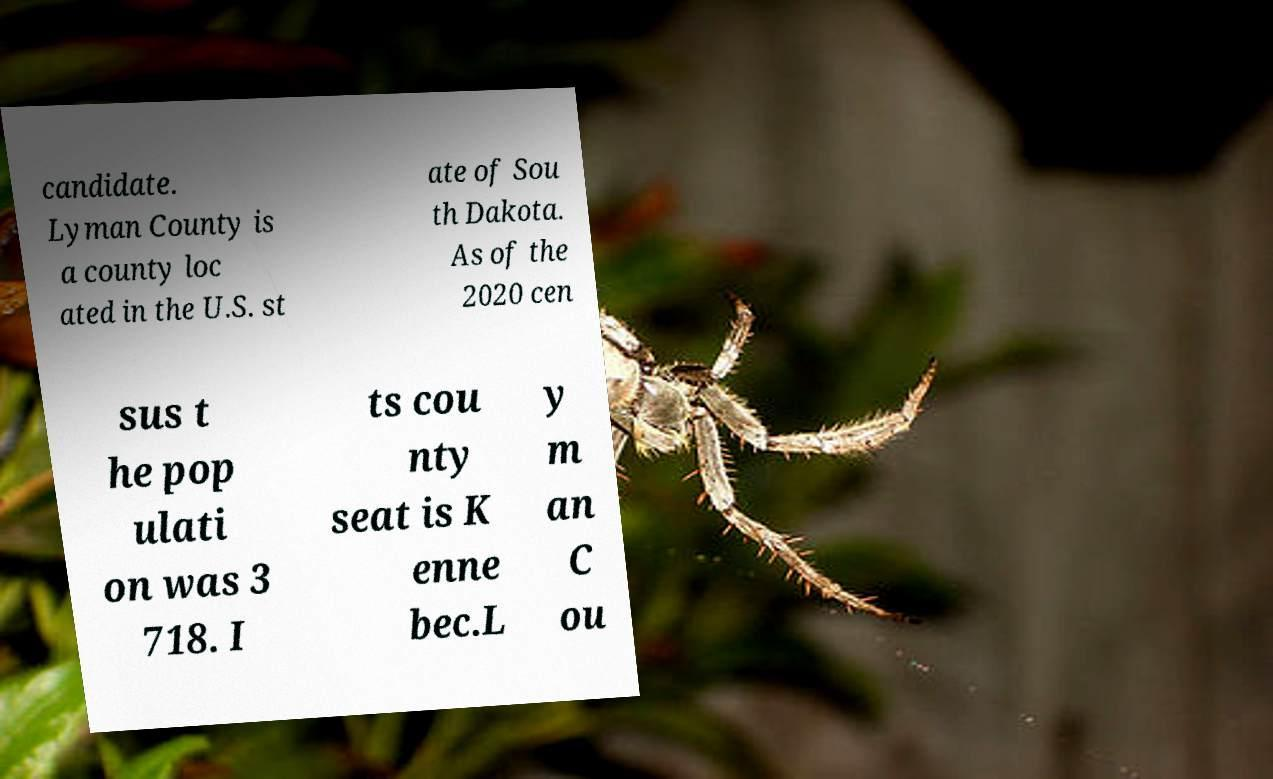Could you assist in decoding the text presented in this image and type it out clearly? candidate. Lyman County is a county loc ated in the U.S. st ate of Sou th Dakota. As of the 2020 cen sus t he pop ulati on was 3 718. I ts cou nty seat is K enne bec.L y m an C ou 